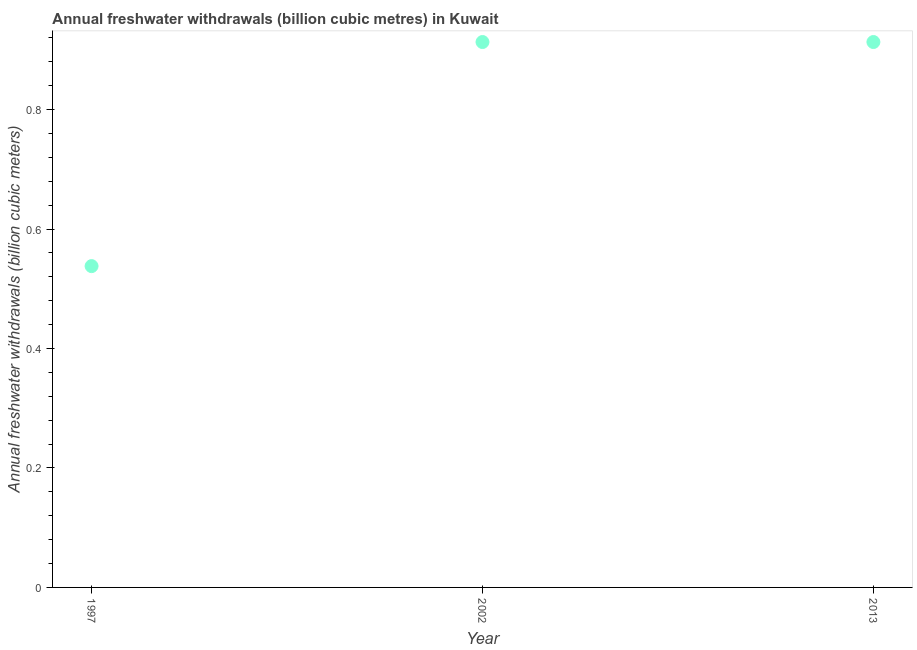What is the annual freshwater withdrawals in 1997?
Your answer should be very brief. 0.54. Across all years, what is the maximum annual freshwater withdrawals?
Give a very brief answer. 0.91. Across all years, what is the minimum annual freshwater withdrawals?
Offer a very short reply. 0.54. In which year was the annual freshwater withdrawals maximum?
Offer a very short reply. 2002. In which year was the annual freshwater withdrawals minimum?
Make the answer very short. 1997. What is the sum of the annual freshwater withdrawals?
Provide a short and direct response. 2.36. What is the difference between the annual freshwater withdrawals in 1997 and 2013?
Provide a succinct answer. -0.38. What is the average annual freshwater withdrawals per year?
Provide a succinct answer. 0.79. What is the median annual freshwater withdrawals?
Offer a terse response. 0.91. Do a majority of the years between 1997 and 2002 (inclusive) have annual freshwater withdrawals greater than 0.48000000000000004 billion cubic meters?
Provide a short and direct response. Yes. What is the ratio of the annual freshwater withdrawals in 1997 to that in 2002?
Ensure brevity in your answer.  0.59. Is the difference between the annual freshwater withdrawals in 1997 and 2002 greater than the difference between any two years?
Offer a very short reply. Yes. What is the difference between the highest and the second highest annual freshwater withdrawals?
Give a very brief answer. 0. What is the difference between the highest and the lowest annual freshwater withdrawals?
Offer a terse response. 0.38. In how many years, is the annual freshwater withdrawals greater than the average annual freshwater withdrawals taken over all years?
Your answer should be very brief. 2. What is the difference between two consecutive major ticks on the Y-axis?
Give a very brief answer. 0.2. Are the values on the major ticks of Y-axis written in scientific E-notation?
Provide a succinct answer. No. Does the graph contain any zero values?
Your response must be concise. No. Does the graph contain grids?
Give a very brief answer. No. What is the title of the graph?
Offer a very short reply. Annual freshwater withdrawals (billion cubic metres) in Kuwait. What is the label or title of the Y-axis?
Your response must be concise. Annual freshwater withdrawals (billion cubic meters). What is the Annual freshwater withdrawals (billion cubic meters) in 1997?
Provide a succinct answer. 0.54. What is the Annual freshwater withdrawals (billion cubic meters) in 2002?
Offer a terse response. 0.91. What is the Annual freshwater withdrawals (billion cubic meters) in 2013?
Give a very brief answer. 0.91. What is the difference between the Annual freshwater withdrawals (billion cubic meters) in 1997 and 2002?
Provide a succinct answer. -0.38. What is the difference between the Annual freshwater withdrawals (billion cubic meters) in 1997 and 2013?
Give a very brief answer. -0.38. What is the difference between the Annual freshwater withdrawals (billion cubic meters) in 2002 and 2013?
Provide a short and direct response. 0. What is the ratio of the Annual freshwater withdrawals (billion cubic meters) in 1997 to that in 2002?
Offer a very short reply. 0.59. What is the ratio of the Annual freshwater withdrawals (billion cubic meters) in 1997 to that in 2013?
Your response must be concise. 0.59. What is the ratio of the Annual freshwater withdrawals (billion cubic meters) in 2002 to that in 2013?
Your answer should be very brief. 1. 